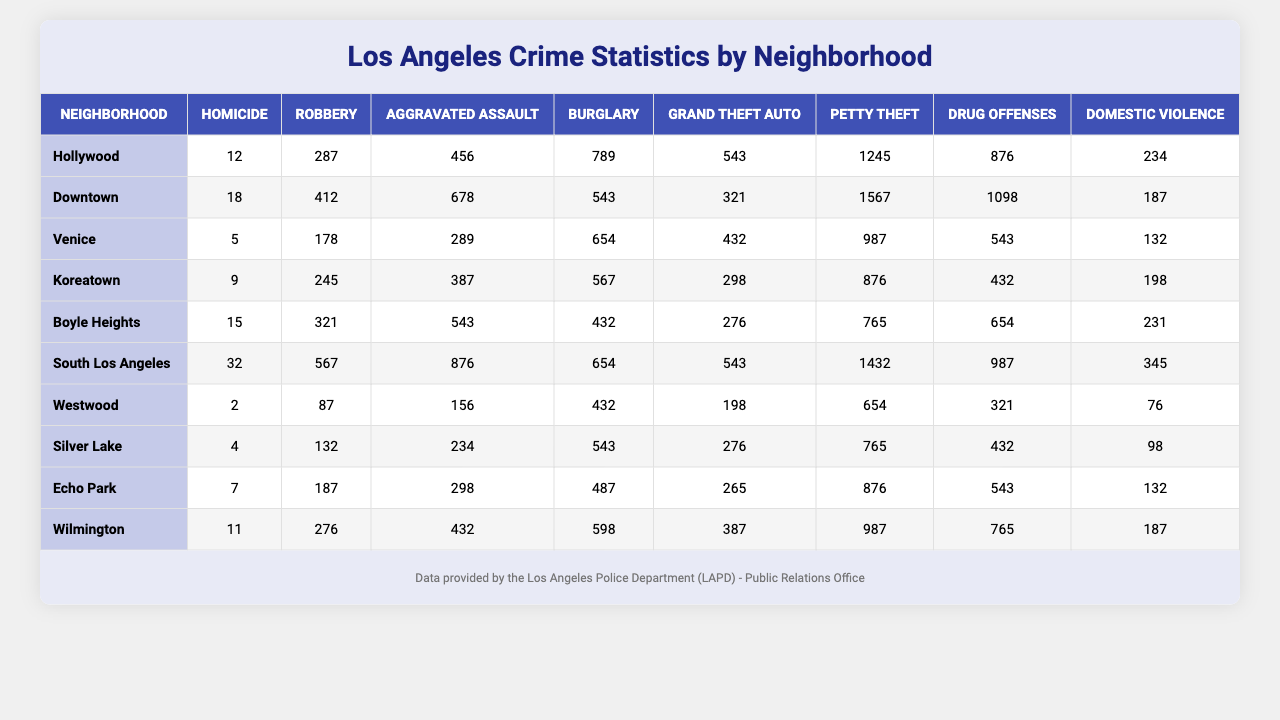What's the neighborhood with the highest number of homicides? By examining the "Homicide" column, South Los Angeles has the highest number of homicides with a total of 32 recorded.
Answer: South Los Angeles Which neighborhood has the lowest rate of robbery? Looking at the "Robbery" column, Westwood has the lowest number of robberies, totaling 87 incidents.
Answer: Westwood What is the total number of aggravated assaults in Boyle Heights and Koreatown? Adding the aggravated assaults from Boyle Heights (543) and Koreatown (387) gives us a total of 930 aggravated assaults.
Answer: 930 Is it true that Hollywood has more drug offenses than Venice? Checking the "Drug Offenses" column shows that Hollywood has 876 drug offenses, whereas Venice has only 543, confirming that Hollywood has more.
Answer: Yes What's the average number of petty thefts across all neighborhoods? To find the average, sum the petty theft numbers (1245 + 1567 + 987 + 876 + 765 + 1432 + 654 + 765 + 876 + 987 = 10263) and divide by 10, resulting in an average of 1026.3 petty thefts.
Answer: 1026.3 Which crime type had the least number of incidents in South Los Angeles? In South Los Angeles, "Grand Theft Auto" had the least number of incidents recorded, totaling 543.
Answer: Grand Theft Auto What is the difference in the number of burglaries between Downtown and Silver Lake? Downtown has 543 burglaries while Silver Lake has 543 as well, meaning the difference is 0.
Answer: 0 Which neighborhood had more drug offenses, Wilmington or Echo Park? Comparing the "Drug Offenses" for Wilmington (765) and Echo Park (543), Wilmington clearly had more drug offenses.
Answer: Wilmington If we combine the number of domestic violence cases in Hollywood and Venice, what is the total? The total for domestic violence cases is calculated by adding Hollywood's (234) and Venice's (132) cases together, which equals 366.
Answer: 366 What crime type recorded the highest incidents in Downtown? The "Robbery" category in Downtown logged the highest incidents at 412.
Answer: Robbery 